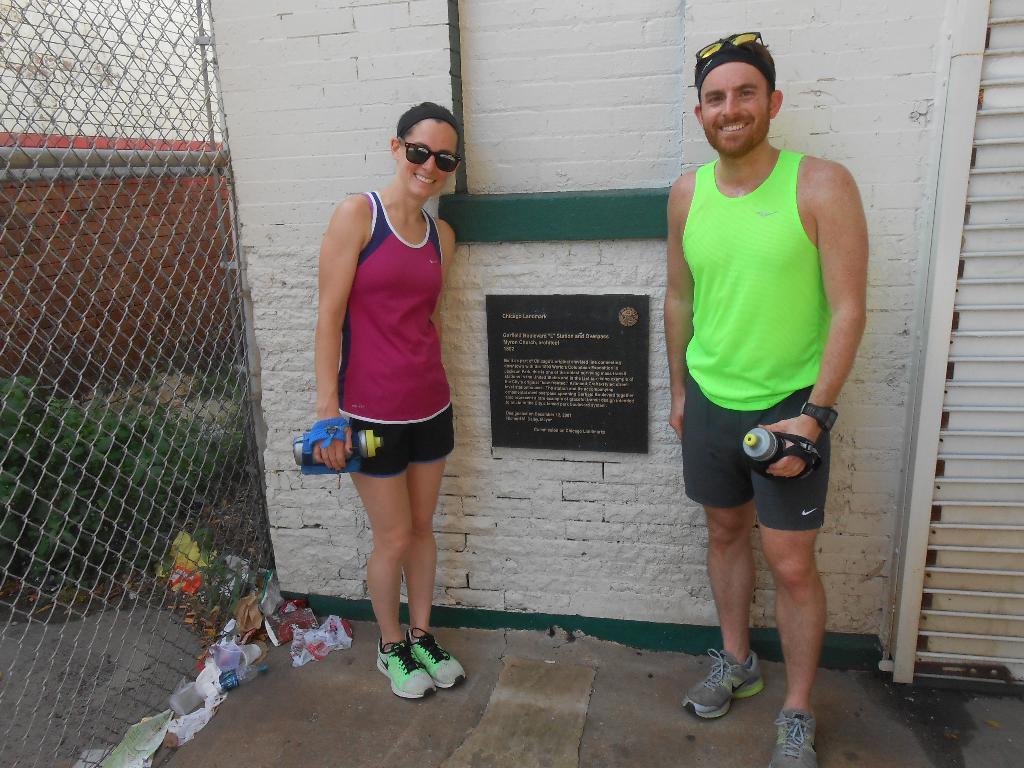Can you describe this image briefly? There is a woman and man standing in the foreground area of the image near a notice board, there is a net fencing, plants and waste materials. 